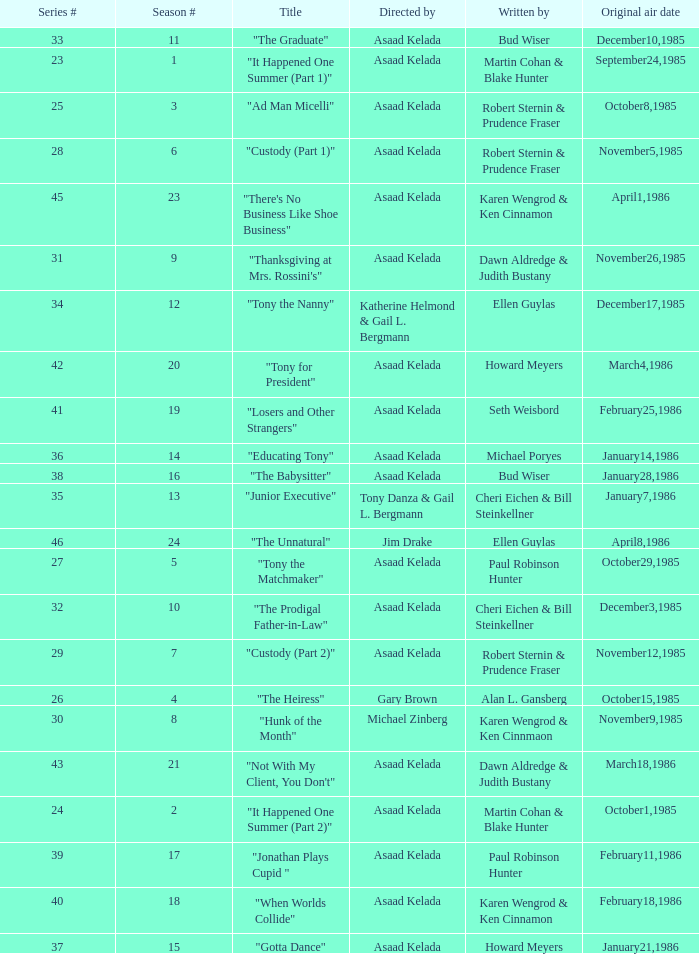What is the date of the episode written by Michael Poryes? January14,1986. 